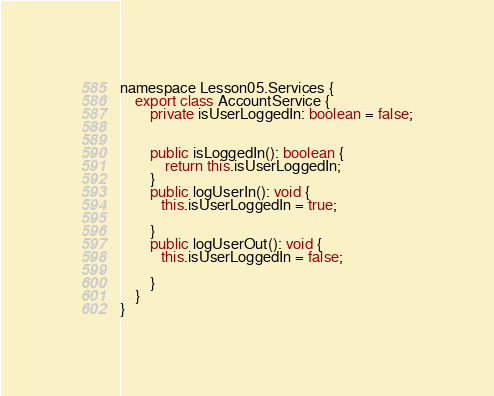Convert code to text. <code><loc_0><loc_0><loc_500><loc_500><_TypeScript_>namespace Lesson05.Services {
    export class AccountService {
        private isUserLoggedIn: boolean = false;

        
        public isLoggedIn(): boolean {
            return this.isUserLoggedIn;
        }
        public logUserIn(): void {
           this.isUserLoggedIn = true;

        }
        public logUserOut(): void {
           this.isUserLoggedIn = false;

        }
    }
}
</code> 